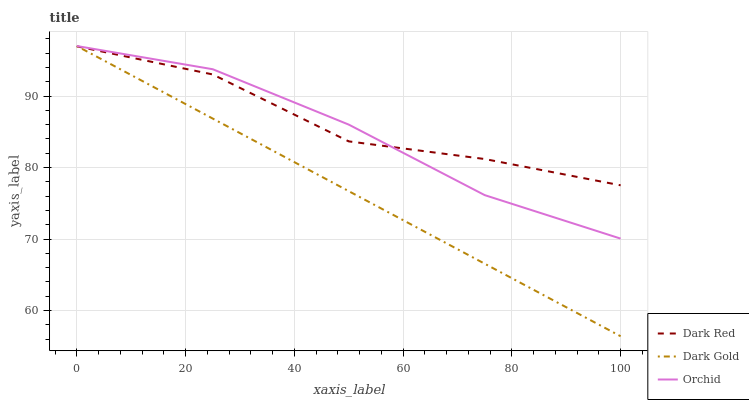Does Dark Gold have the minimum area under the curve?
Answer yes or no. Yes. Does Dark Red have the maximum area under the curve?
Answer yes or no. Yes. Does Orchid have the minimum area under the curve?
Answer yes or no. No. Does Orchid have the maximum area under the curve?
Answer yes or no. No. Is Dark Gold the smoothest?
Answer yes or no. Yes. Is Dark Red the roughest?
Answer yes or no. Yes. Is Orchid the smoothest?
Answer yes or no. No. Is Orchid the roughest?
Answer yes or no. No. Does Dark Gold have the lowest value?
Answer yes or no. Yes. Does Orchid have the lowest value?
Answer yes or no. No. Does Dark Gold have the highest value?
Answer yes or no. Yes. Does Dark Red intersect Orchid?
Answer yes or no. Yes. Is Dark Red less than Orchid?
Answer yes or no. No. Is Dark Red greater than Orchid?
Answer yes or no. No. 